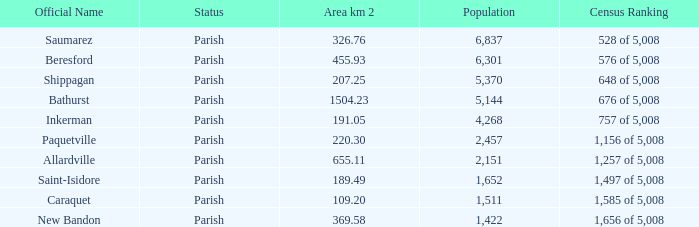What is the Area of the Allardville Parish with a Population smaller than 2,151? None. 